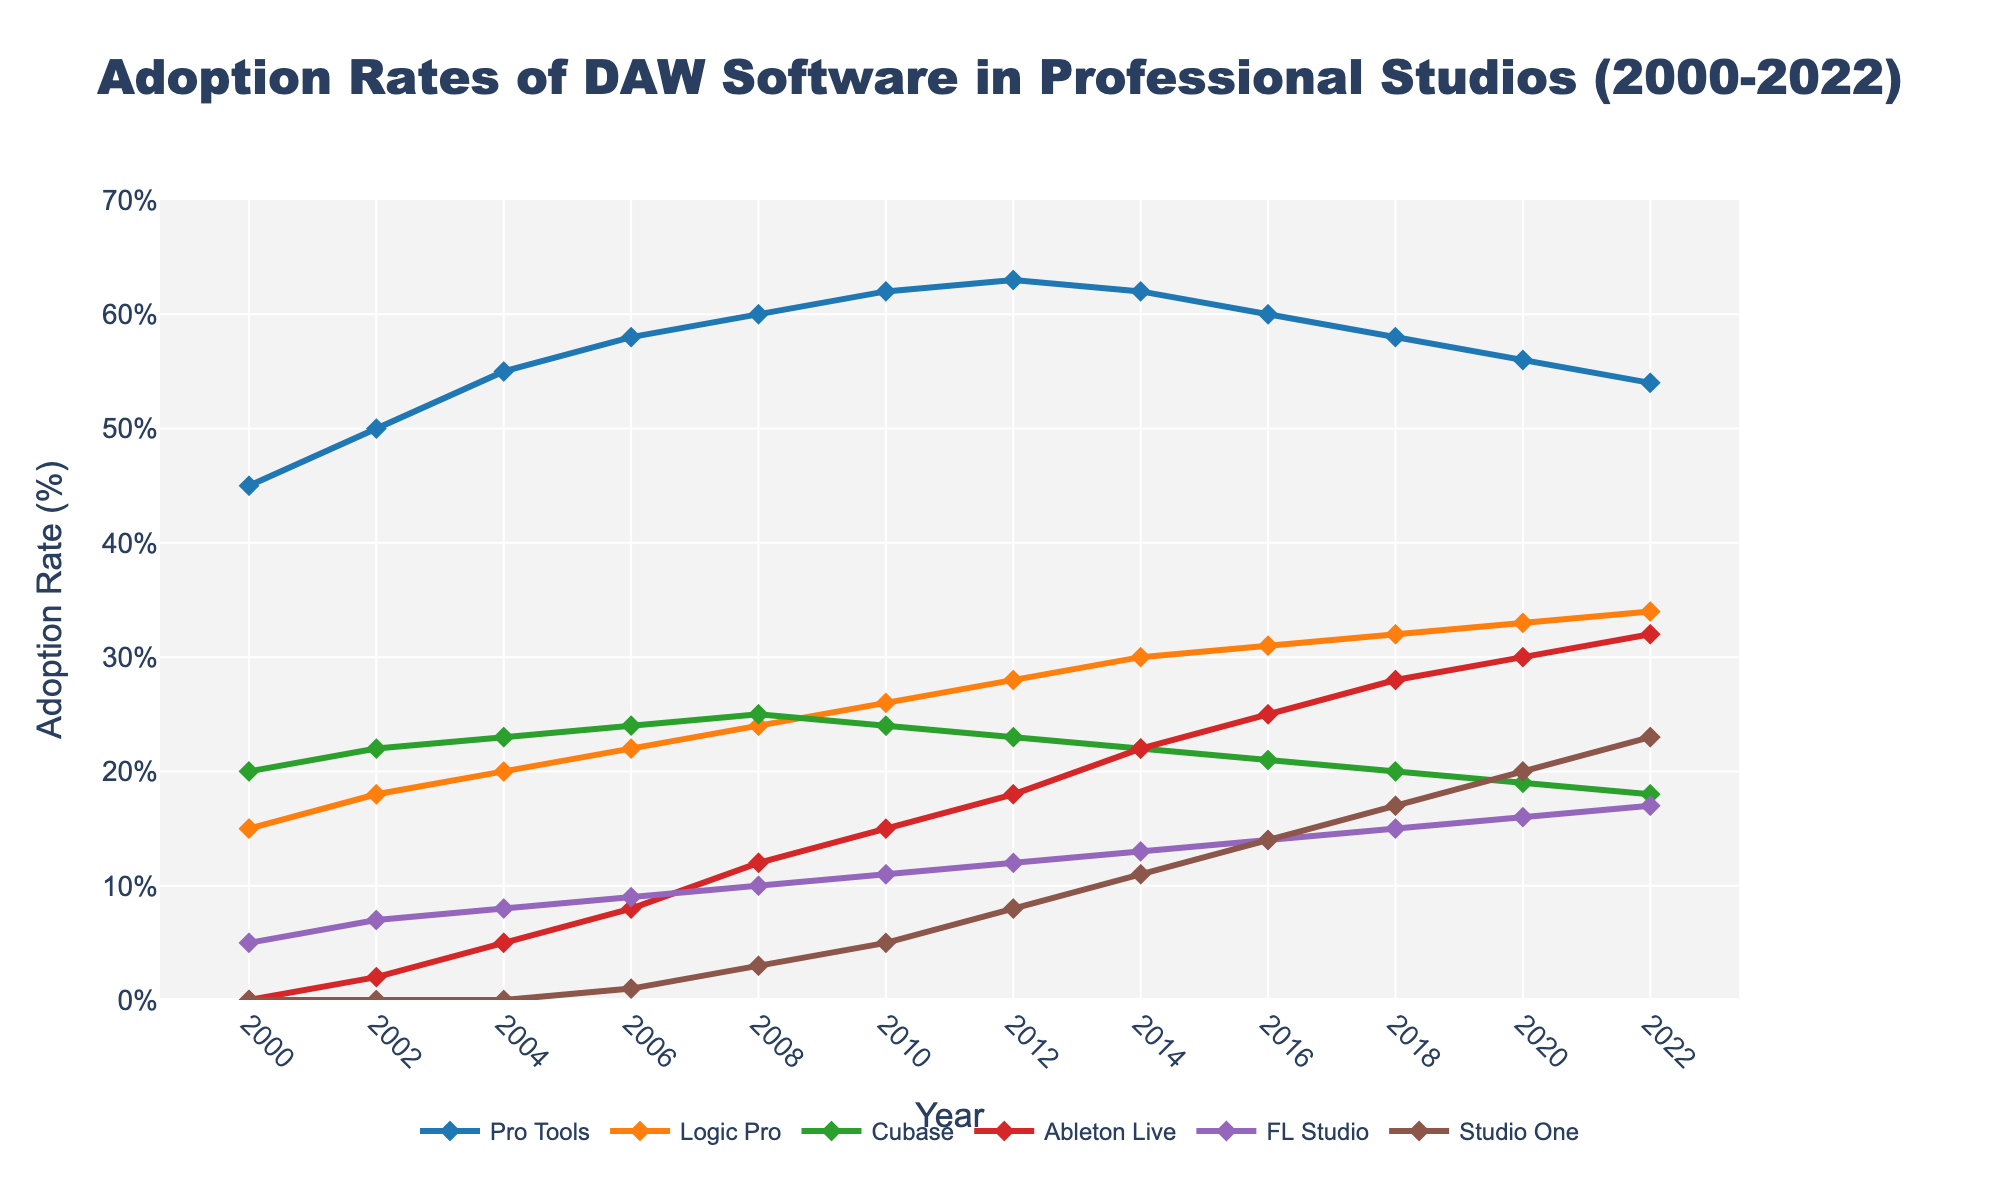What DAW had the highest adoption rate in 2022? Look at the end of all lines in the chart at the year 2022, and find the highest point on the y-axis.
Answer: Pro Tools Which DAW had the fastest growth rate between 2006 and 2008? Compare the slopes of all DAW lines between 2006 and 2008. The steepest slope indicates the fastest growth.
Answer: Ableton Live What is the difference in adoption rates between Pro Tools and Logic Pro in 2020? Find the points for Pro Tools and Logic Pro in 2020. Calculate the difference: 56 - 33 = 23.
Answer: 23% How many DAWs reached adoption rates of 30% or more by 2022? Count the number of lines (DAWs) that are at or above the 30% mark on the y-axis in 2022.
Answer: 2 Between which consecutive years did Studio One see its greatest increase in adoption rate? Evaluate the gap between each consecutive year's adoption rates for Studio One and identify the largest increase.
Answer: 2018 to 2020 Which DAW had a stable adoption rate close to 20% over the years? Look for the DAW line that stays around the 20% mark horizontally across the years.
Answer: Cubase Which DAW exhibited a steady decline in adoption rates from 2010 onwards? Identify the DAW line that consistently moves downward in its slope from 2010 to 2022.
Answer: Pro Tools What was the average adoption rate of FL Studio from 2008 to 2018? Sum the adoption rates of FL Studio at each interval between 2008 and 2018 and divide by the number of intervals: (10+11+12+13+14+15) / 6 = 12.5.
Answer: 12.5% Compare the adoption rates of Cubase and Studio One in 2014. Locate the adoption rates of both Cubase and Studio One in the year 2014 and find the difference. 22 - 11 = 11.
Answer: Cubase's adoption rate is 11% higher than Studio One What is the trend in the adoption rate of Ableton Live from 2000 to 2022? Identify the slope of the Ableton Live line from 2000 to 2022. Observe if the line is generally ascending, descending, or stable.
Answer: Increasing 